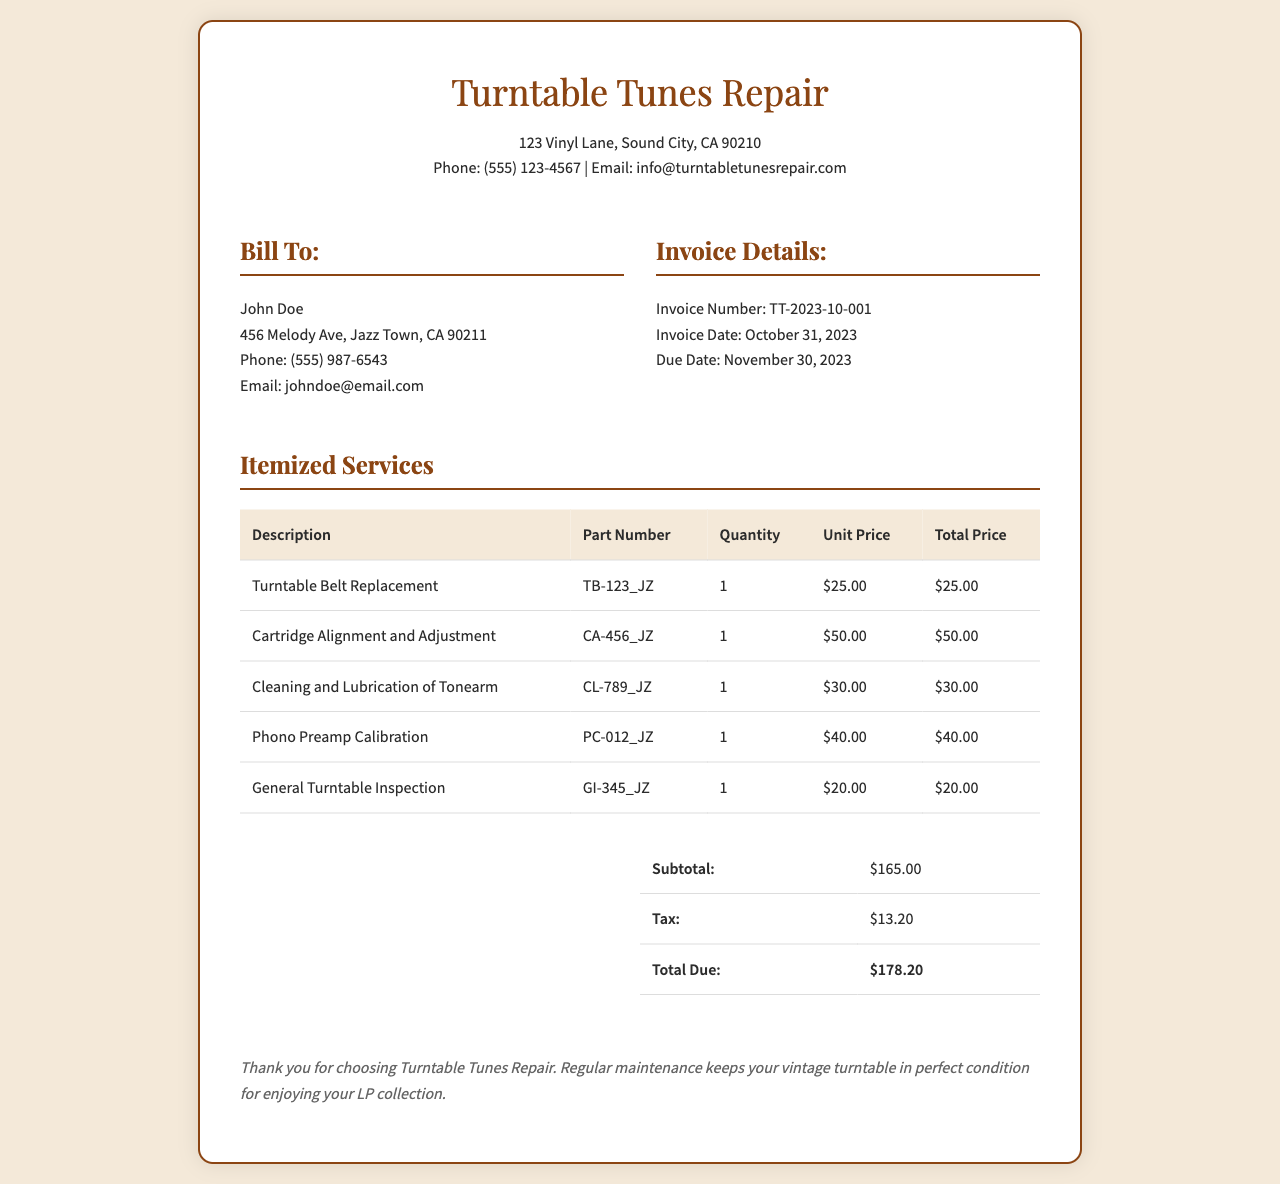What is the invoice number? The invoice number listed in the document is TT-2023-10-001.
Answer: TT-2023-10-001 When is the invoice date? The invoice date specified in the document is October 31, 2023.
Answer: October 31, 2023 How much is the tax on the invoice? The tax on the invoice is calculated as shown in the summary table, which is $13.20.
Answer: $13.20 What service is provided for cleaning the tonearm? The document states "Cleaning and Lubrication of Tonearm" as one of the services provided.
Answer: Cleaning and Lubrication of Tonearm What is the total due amount? The total amount due at the bottom of the summary table is $178.20.
Answer: $178.20 How many services were listed on the invoice? The invoice lists a total of five different services provided.
Answer: 5 What is the price of the turntable belt replacement? The unit price for the turntable belt replacement service is $25.00 as indicated in the table.
Answer: $25.00 What is the due date for the invoice? The due date noted in the document is November 30, 2023.
Answer: November 30, 2023 Who is the invoice billed to? The document indicates that the invoice is billed to John Doe.
Answer: John Doe 